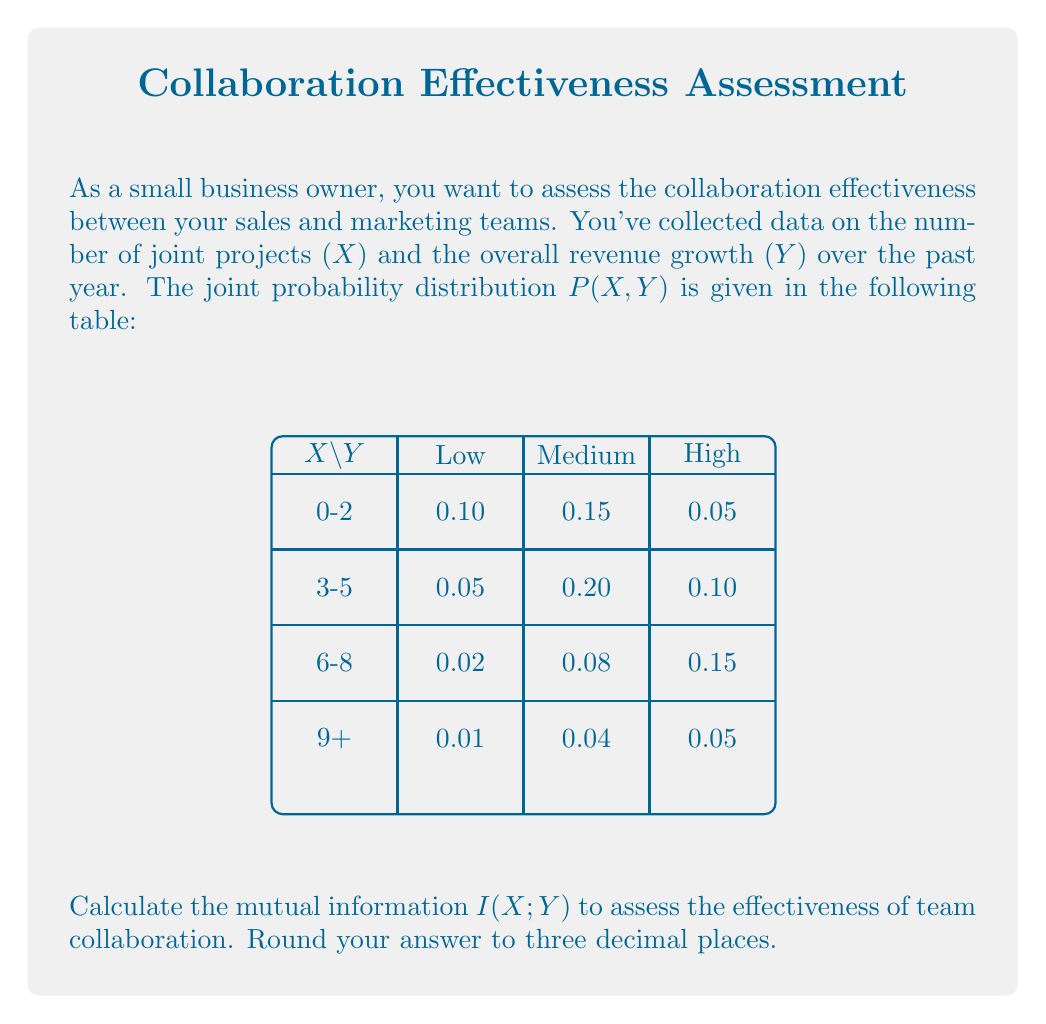Could you help me with this problem? To calculate the mutual information I(X;Y), we'll follow these steps:

1) First, we need to calculate the marginal probabilities P(X) and P(Y):

   P(X = 0-2) = 0.10 + 0.15 + 0.05 = 0.30
   P(X = 3-5) = 0.05 + 0.20 + 0.10 = 0.35
   P(X = 6-8) = 0.02 + 0.08 + 0.15 = 0.25
   P(X = 9+)  = 0.01 + 0.04 + 0.05 = 0.10

   P(Y = Low)    = 0.10 + 0.05 + 0.02 + 0.01 = 0.18
   P(Y = Medium) = 0.15 + 0.20 + 0.08 + 0.04 = 0.47
   P(Y = High)   = 0.05 + 0.10 + 0.15 + 0.05 = 0.35

2) The mutual information is defined as:

   $$I(X;Y) = \sum_{x}\sum_{y} P(x,y) \log_2\frac{P(x,y)}{P(x)P(y)}$$

3) Let's calculate each term:

   $0.10 \log_2\frac{0.10}{0.30 \cdot 0.18} = 0.10 \log_2 1.852 = 0.0889$
   $0.15 \log_2\frac{0.15}{0.30 \cdot 0.47} = 0.15 \log_2 1.064 = 0.0133$
   $0.05 \log_2\frac{0.05}{0.30 \cdot 0.35} = 0.05 \log_2 0.476 = -0.0547$
   $0.05 \log_2\frac{0.05}{0.35 \cdot 0.18} = 0.05 \log_2 0.794 = -0.0177$
   $0.20 \log_2\frac{0.20}{0.35 \cdot 0.47} = 0.20 \log_2 1.214 = 0.0522$
   $0.10 \log_2\frac{0.10}{0.35 \cdot 0.35} = 0.10 \log_2 0.816 = -0.0270$
   $0.02 \log_2\frac{0.02}{0.25 \cdot 0.18} = 0.02 \log_2 0.444 = -0.0230$
   $0.08 \log_2\frac{0.08}{0.25 \cdot 0.47} = 0.08 \log_2 0.681 = -0.0371$
   $0.15 \log_2\frac{0.15}{0.25 \cdot 0.35} = 0.15 \log_2 1.714 = 0.1348$
   $0.01 \log_2\frac{0.01}{0.10 \cdot 0.18} = 0.01 \log_2 0.556 = -0.0058$
   $0.04 \log_2\frac{0.04}{0.10 \cdot 0.47} = 0.04 \log_2 0.851 = -0.0083$
   $0.05 \log_2\frac{0.05}{0.10 \cdot 0.35} = 0.05 \log_2 1.429 = 0.0305$

4) Sum all these terms:

   I(X;Y) = 0.1461 bits

5) Rounding to three decimal places:

   I(X;Y) ≈ 0.146 bits
Answer: 0.146 bits 